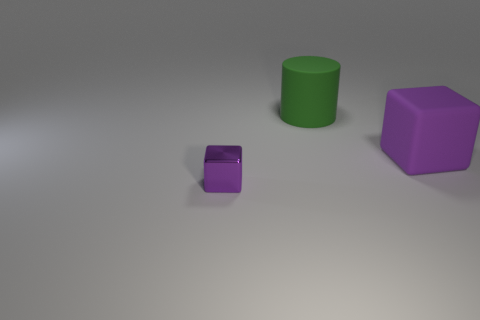Are there any other things that are the same color as the metal block?
Offer a very short reply. Yes. What shape is the object that is behind the tiny purple metallic object and in front of the green thing?
Your answer should be very brief. Cube. There is a green object right of the tiny purple metallic cube; what size is it?
Provide a short and direct response. Large. How many large purple blocks are in front of the purple thing on the left side of the purple block that is behind the small metallic object?
Give a very brief answer. 0. There is a purple rubber object; are there any big purple rubber cubes left of it?
Give a very brief answer. No. How many other objects are there of the same size as the green cylinder?
Ensure brevity in your answer.  1. There is a object that is both in front of the big green cylinder and behind the tiny purple metallic cube; what material is it made of?
Your answer should be compact. Rubber. There is a purple object that is to the right of the small metal block; is it the same shape as the small purple object in front of the large matte cylinder?
Give a very brief answer. Yes. Is there any other thing that has the same material as the tiny purple object?
Your answer should be compact. No. There is a purple thing to the right of the cube that is left of the purple block behind the tiny purple object; what is its shape?
Your answer should be very brief. Cube. 